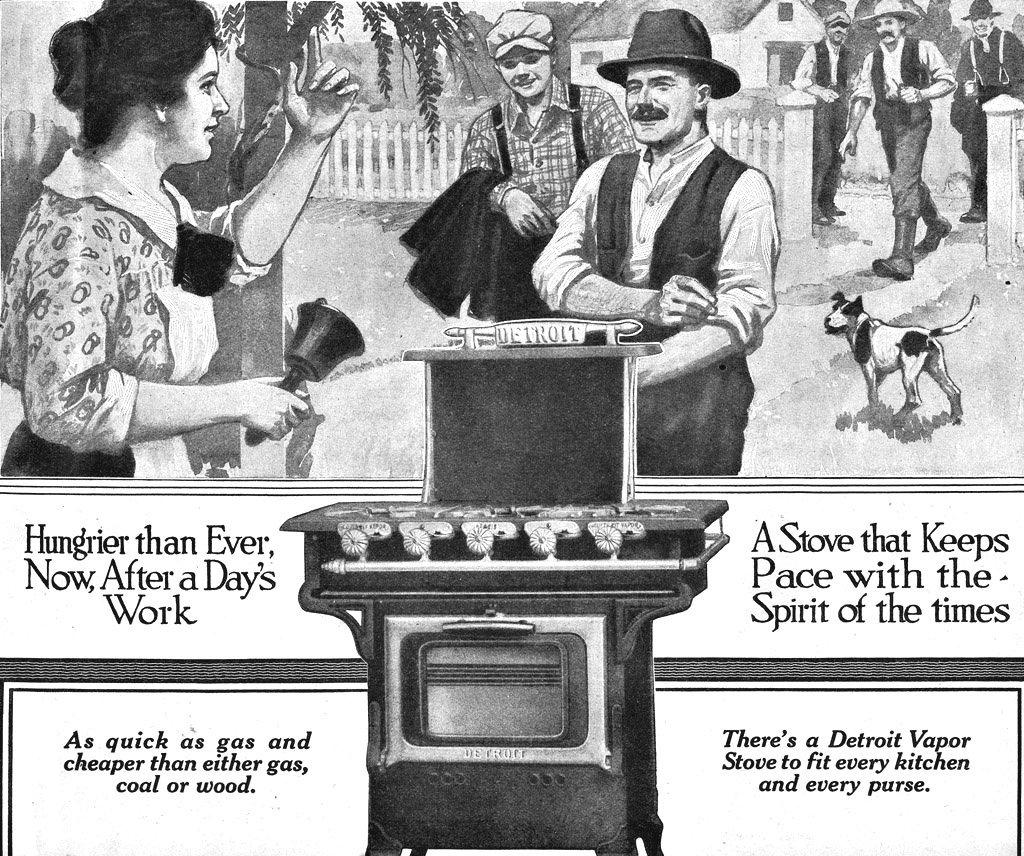<image>
Write a terse but informative summary of the picture. An old fashion black and white ad for a Detroit Vapor stove. 